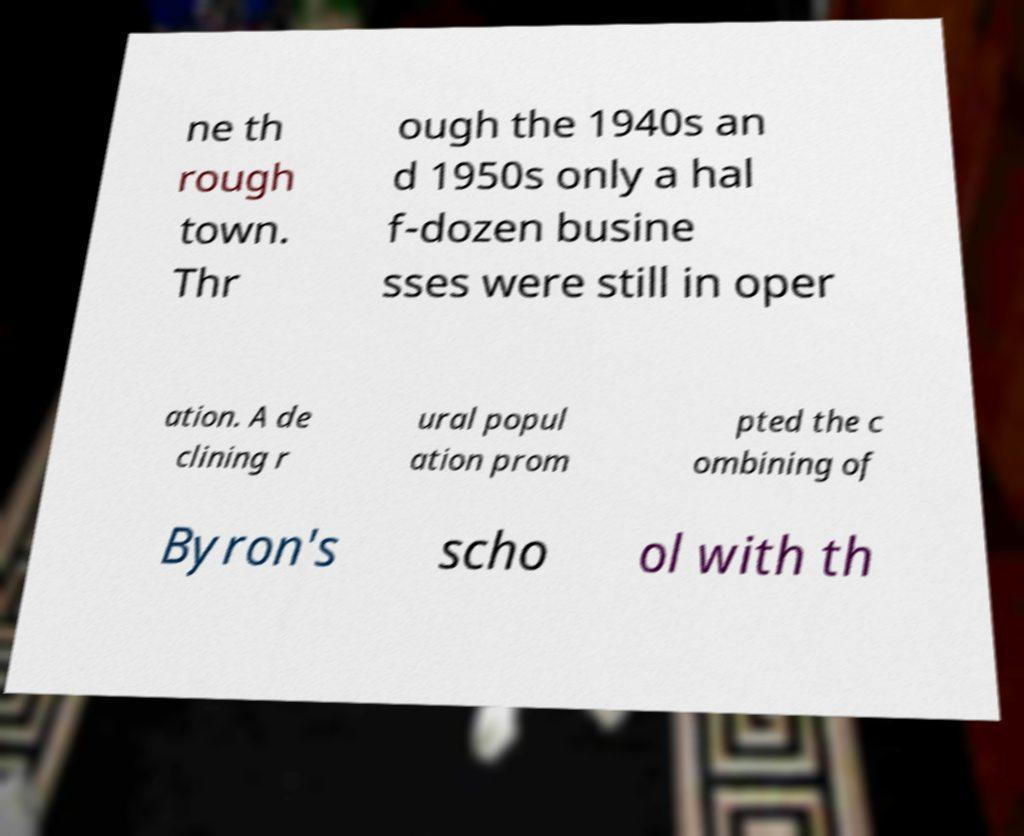I need the written content from this picture converted into text. Can you do that? ne th rough town. Thr ough the 1940s an d 1950s only a hal f-dozen busine sses were still in oper ation. A de clining r ural popul ation prom pted the c ombining of Byron's scho ol with th 